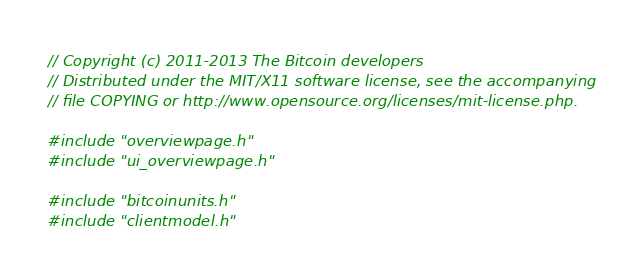<code> <loc_0><loc_0><loc_500><loc_500><_C++_>// Copyright (c) 2011-2013 The Bitcoin developers
// Distributed under the MIT/X11 software license, see the accompanying
// file COPYING or http://www.opensource.org/licenses/mit-license.php.

#include "overviewpage.h"
#include "ui_overviewpage.h"

#include "bitcoinunits.h"
#include "clientmodel.h"</code> 